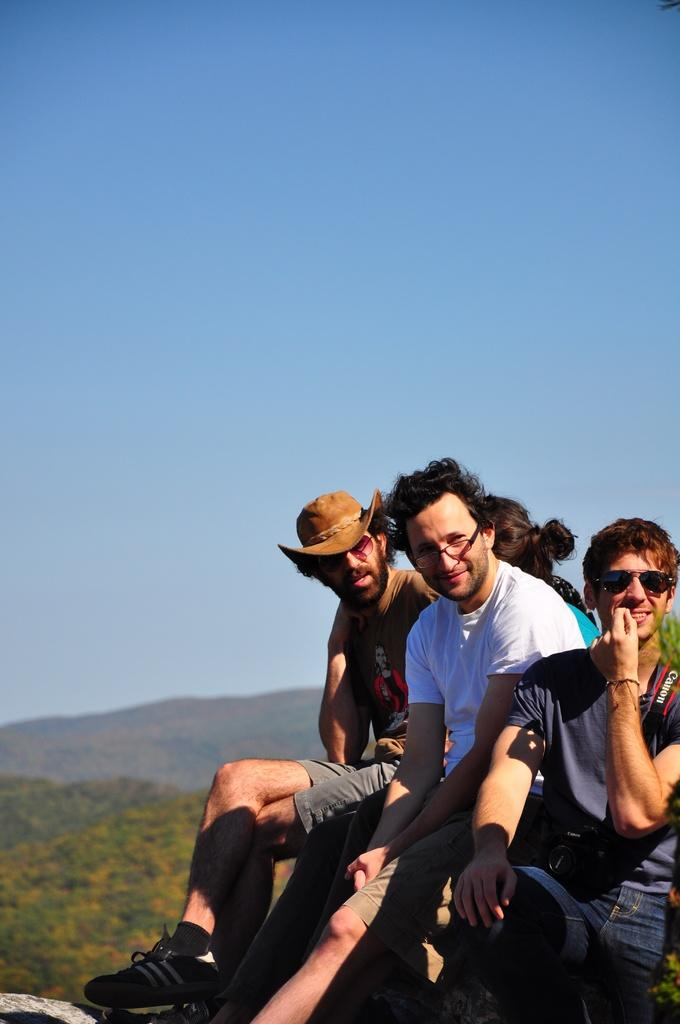What are the people in the image doing? The persons in the front of the image are sitting. What is the facial expression of the people in the image? The persons are smiling. What type of surface can be seen in the background of the image? There is grass on the ground in the background of the image. What type of advice can be seen written on the shelf in the image? There is no shelf present in the image, so no advice can be seen written on it. Can you tell me how many geese are visible in the image? There are no geese present in the image. 